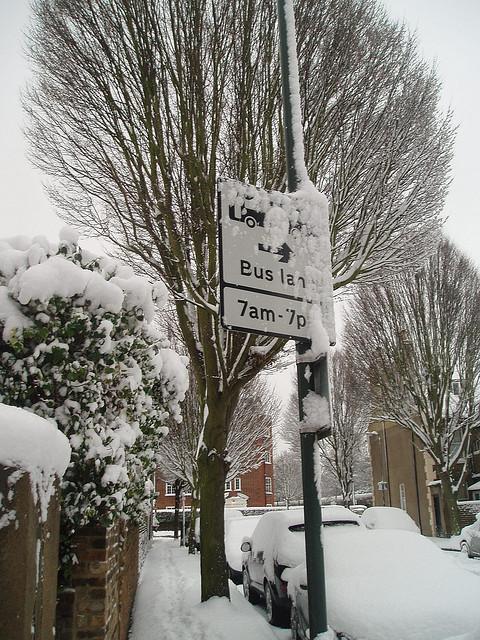How many cars are visible?
Give a very brief answer. 2. 